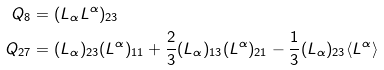Convert formula to latex. <formula><loc_0><loc_0><loc_500><loc_500>Q _ { 8 } & = ( L _ { \alpha } L ^ { \alpha } ) _ { 2 3 } \\ Q _ { 2 7 } & = ( { L _ { \alpha } } ) _ { 2 3 } ( L ^ { \alpha } ) _ { 1 1 } + \frac { 2 } { 3 } ( L _ { \alpha } ) _ { 1 3 } ( L ^ { \alpha } ) _ { 2 1 } - \frac { 1 } { 3 } ( L _ { \alpha } ) _ { 2 3 } \langle L ^ { \alpha } \rangle</formula> 